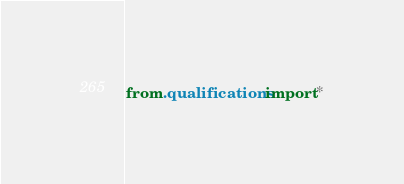<code> <loc_0><loc_0><loc_500><loc_500><_Python_>from .qualifications import *</code> 